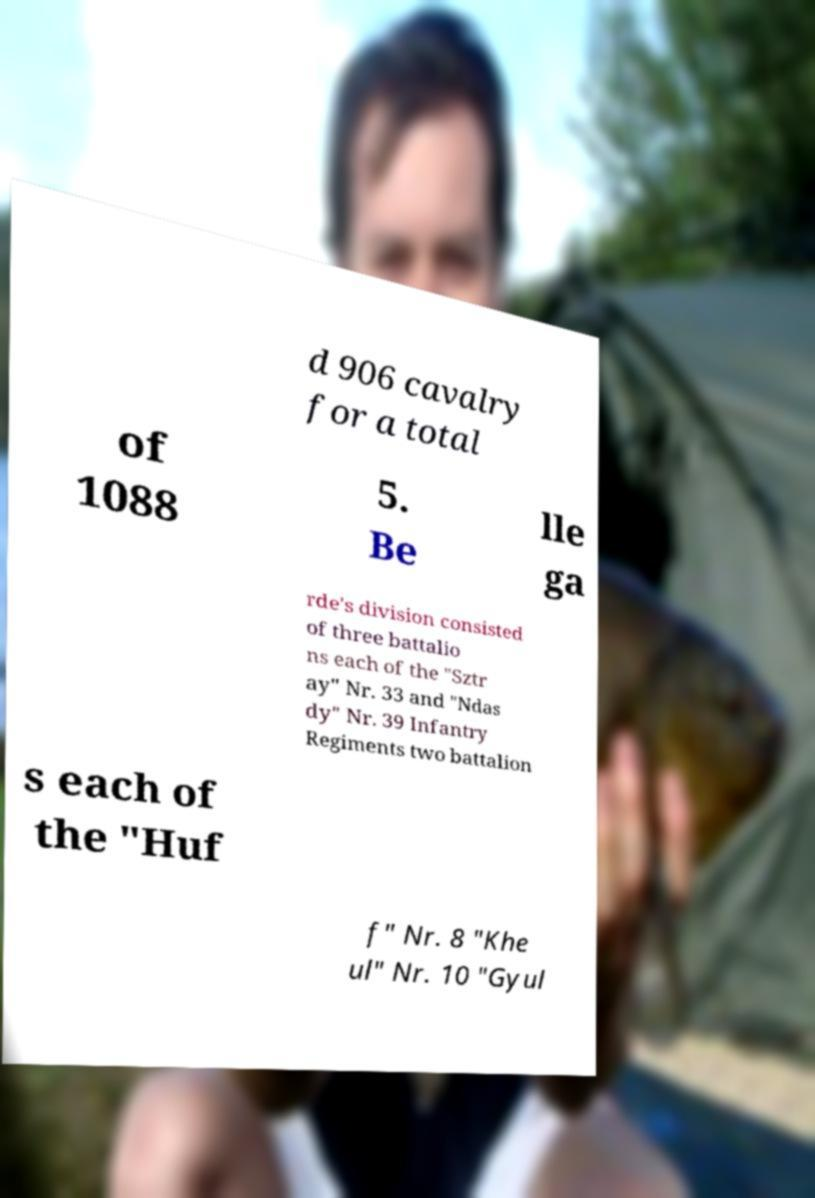Could you extract and type out the text from this image? d 906 cavalry for a total of 1088 5. Be lle ga rde's division consisted of three battalio ns each of the "Sztr ay" Nr. 33 and "Ndas dy" Nr. 39 Infantry Regiments two battalion s each of the "Huf f" Nr. 8 "Khe ul" Nr. 10 "Gyul 